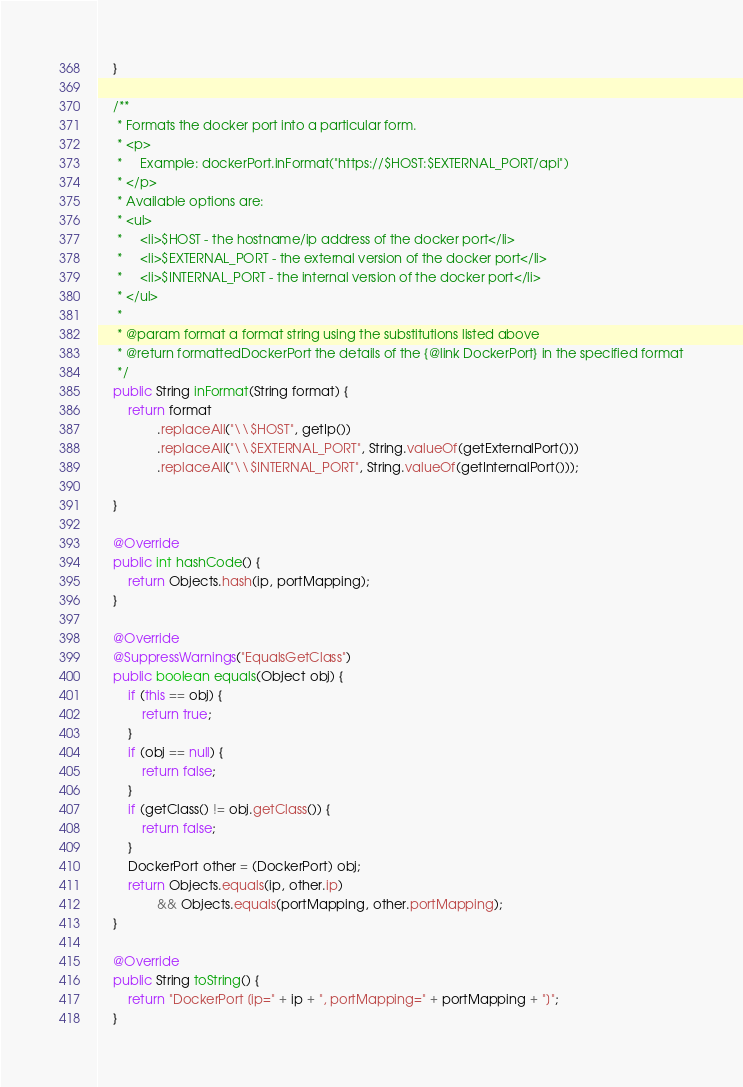<code> <loc_0><loc_0><loc_500><loc_500><_Java_>    }

    /**
     * Formats the docker port into a particular form.
     * <p>
     *     Example: dockerPort.inFormat("https://$HOST:$EXTERNAL_PORT/api")
     * </p>
     * Available options are:
     * <ul>
     *     <li>$HOST - the hostname/ip address of the docker port</li>
     *     <li>$EXTERNAL_PORT - the external version of the docker port</li>
     *     <li>$INTERNAL_PORT - the internal version of the docker port</li>
     * </ul>
     *
     * @param format a format string using the substitutions listed above
     * @return formattedDockerPort the details of the {@link DockerPort} in the specified format
     */
    public String inFormat(String format) {
        return format
                .replaceAll("\\$HOST", getIp())
                .replaceAll("\\$EXTERNAL_PORT", String.valueOf(getExternalPort()))
                .replaceAll("\\$INTERNAL_PORT", String.valueOf(getInternalPort()));

    }

    @Override
    public int hashCode() {
        return Objects.hash(ip, portMapping);
    }

    @Override
    @SuppressWarnings("EqualsGetClass")
    public boolean equals(Object obj) {
        if (this == obj) {
            return true;
        }
        if (obj == null) {
            return false;
        }
        if (getClass() != obj.getClass()) {
            return false;
        }
        DockerPort other = (DockerPort) obj;
        return Objects.equals(ip, other.ip)
                && Objects.equals(portMapping, other.portMapping);
    }

    @Override
    public String toString() {
        return "DockerPort [ip=" + ip + ", portMapping=" + portMapping + "]";
    }</code> 